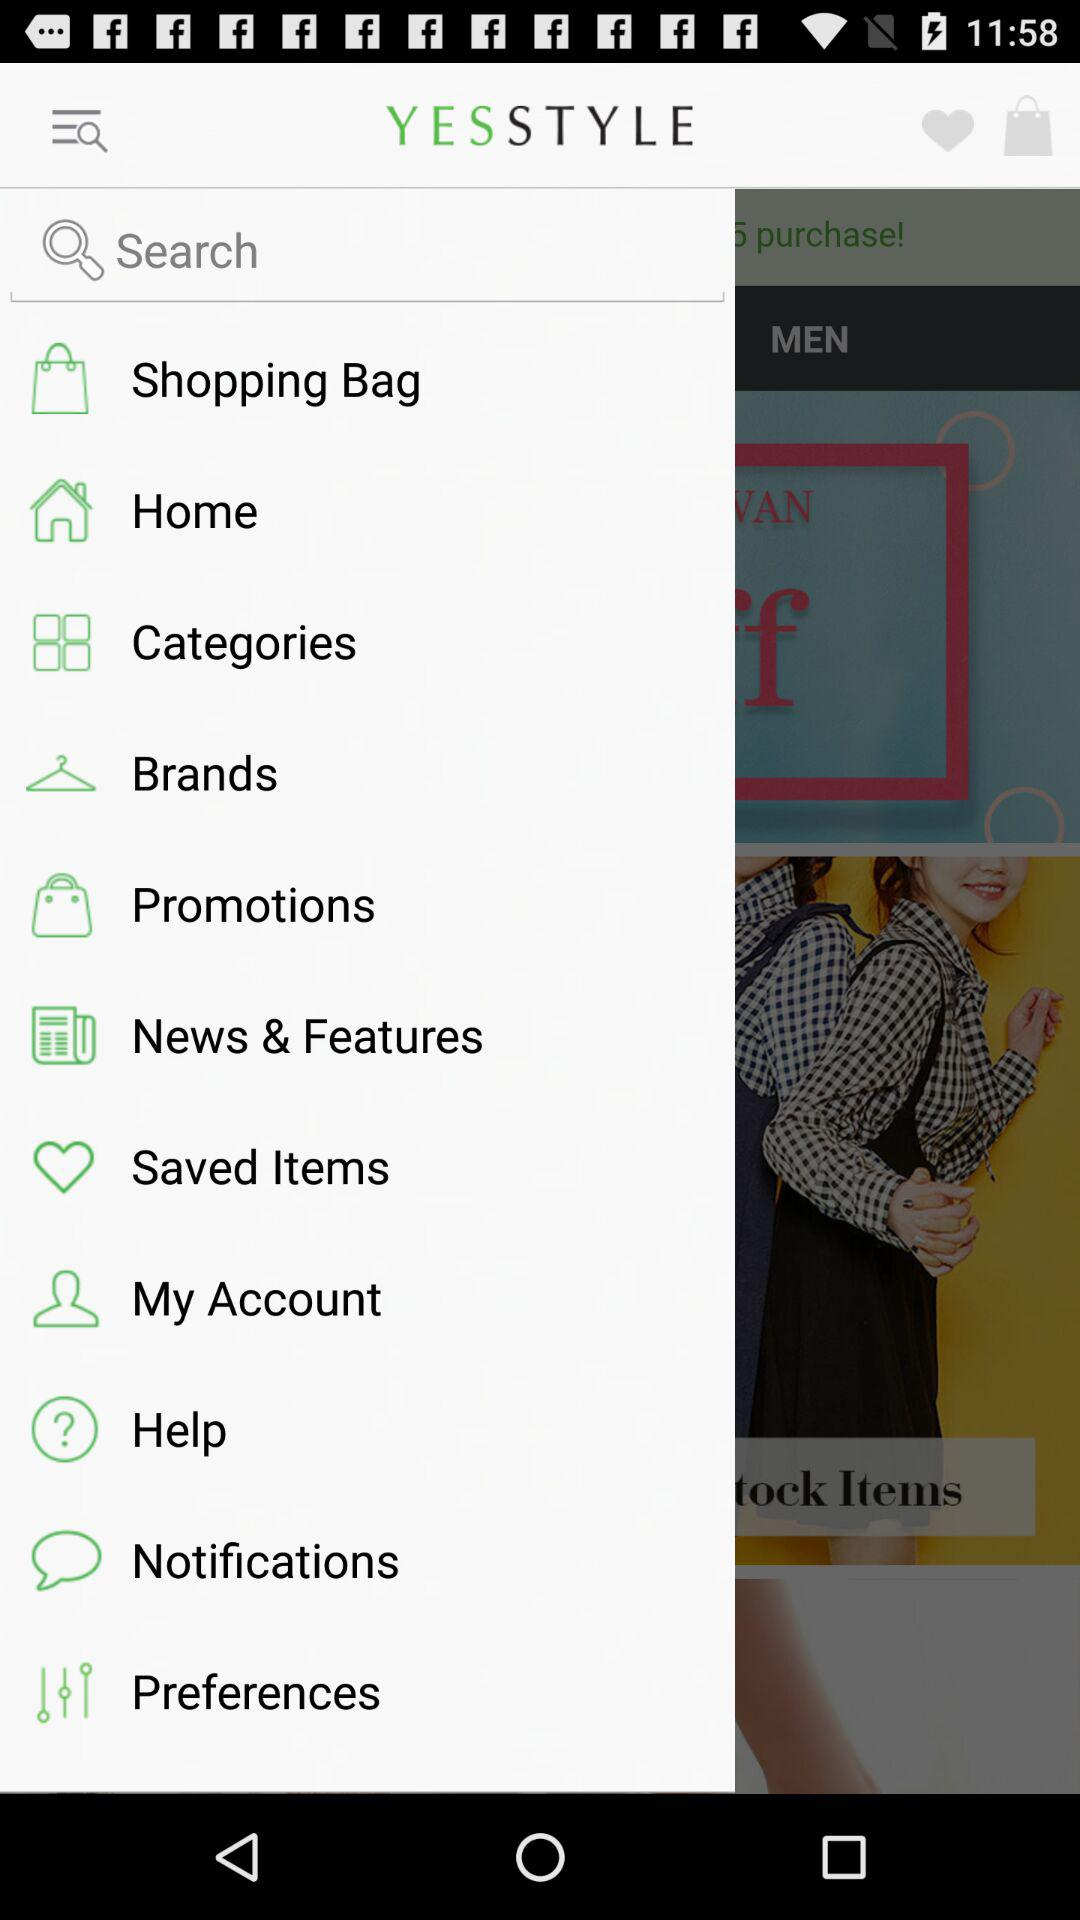What is the application name? The application name is "YESSTYLE". 